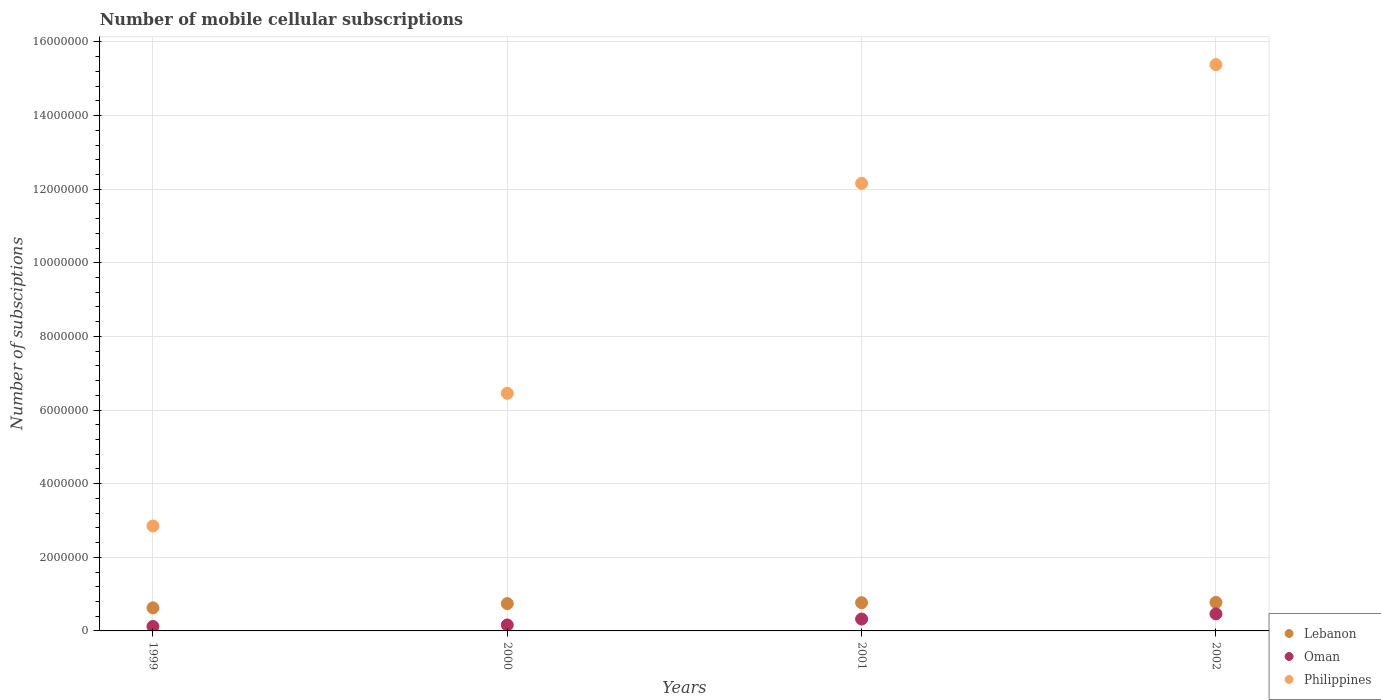How many different coloured dotlines are there?
Provide a short and direct response. 3. Is the number of dotlines equal to the number of legend labels?
Keep it short and to the point. Yes. What is the number of mobile cellular subscriptions in Philippines in 1999?
Ensure brevity in your answer.  2.85e+06. Across all years, what is the maximum number of mobile cellular subscriptions in Philippines?
Your answer should be compact. 1.54e+07. Across all years, what is the minimum number of mobile cellular subscriptions in Oman?
Provide a short and direct response. 1.21e+05. In which year was the number of mobile cellular subscriptions in Oman minimum?
Give a very brief answer. 1999. What is the total number of mobile cellular subscriptions in Lebanon in the graph?
Ensure brevity in your answer.  2.91e+06. What is the difference between the number of mobile cellular subscriptions in Philippines in 2001 and that in 2002?
Your response must be concise. -3.22e+06. What is the difference between the number of mobile cellular subscriptions in Oman in 2000 and the number of mobile cellular subscriptions in Philippines in 2001?
Ensure brevity in your answer.  -1.20e+07. What is the average number of mobile cellular subscriptions in Lebanon per year?
Provide a succinct answer. 7.28e+05. In the year 2001, what is the difference between the number of mobile cellular subscriptions in Philippines and number of mobile cellular subscriptions in Lebanon?
Your response must be concise. 1.14e+07. What is the ratio of the number of mobile cellular subscriptions in Philippines in 2000 to that in 2002?
Keep it short and to the point. 0.42. What is the difference between the highest and the second highest number of mobile cellular subscriptions in Oman?
Keep it short and to the point. 1.40e+05. What is the difference between the highest and the lowest number of mobile cellular subscriptions in Oman?
Your answer should be very brief. 3.42e+05. In how many years, is the number of mobile cellular subscriptions in Philippines greater than the average number of mobile cellular subscriptions in Philippines taken over all years?
Your response must be concise. 2. Is it the case that in every year, the sum of the number of mobile cellular subscriptions in Oman and number of mobile cellular subscriptions in Philippines  is greater than the number of mobile cellular subscriptions in Lebanon?
Provide a succinct answer. Yes. Does the number of mobile cellular subscriptions in Lebanon monotonically increase over the years?
Your answer should be compact. Yes. Is the number of mobile cellular subscriptions in Lebanon strictly greater than the number of mobile cellular subscriptions in Philippines over the years?
Ensure brevity in your answer.  No. Is the number of mobile cellular subscriptions in Philippines strictly less than the number of mobile cellular subscriptions in Oman over the years?
Give a very brief answer. No. What is the difference between two consecutive major ticks on the Y-axis?
Your response must be concise. 2.00e+06. Does the graph contain any zero values?
Provide a succinct answer. No. Where does the legend appear in the graph?
Your response must be concise. Bottom right. How many legend labels are there?
Offer a terse response. 3. How are the legend labels stacked?
Your answer should be very brief. Vertical. What is the title of the graph?
Offer a terse response. Number of mobile cellular subscriptions. Does "Georgia" appear as one of the legend labels in the graph?
Your response must be concise. No. What is the label or title of the Y-axis?
Your answer should be compact. Number of subsciptions. What is the Number of subsciptions in Lebanon in 1999?
Ensure brevity in your answer.  6.27e+05. What is the Number of subsciptions of Oman in 1999?
Ensure brevity in your answer.  1.21e+05. What is the Number of subsciptions of Philippines in 1999?
Make the answer very short. 2.85e+06. What is the Number of subsciptions in Lebanon in 2000?
Make the answer very short. 7.43e+05. What is the Number of subsciptions of Oman in 2000?
Your answer should be very brief. 1.62e+05. What is the Number of subsciptions in Philippines in 2000?
Your answer should be compact. 6.45e+06. What is the Number of subsciptions in Lebanon in 2001?
Your answer should be compact. 7.67e+05. What is the Number of subsciptions of Oman in 2001?
Ensure brevity in your answer.  3.23e+05. What is the Number of subsciptions in Philippines in 2001?
Ensure brevity in your answer.  1.22e+07. What is the Number of subsciptions of Lebanon in 2002?
Ensure brevity in your answer.  7.75e+05. What is the Number of subsciptions in Oman in 2002?
Your answer should be compact. 4.63e+05. What is the Number of subsciptions in Philippines in 2002?
Make the answer very short. 1.54e+07. Across all years, what is the maximum Number of subsciptions in Lebanon?
Provide a short and direct response. 7.75e+05. Across all years, what is the maximum Number of subsciptions of Oman?
Provide a succinct answer. 4.63e+05. Across all years, what is the maximum Number of subsciptions of Philippines?
Give a very brief answer. 1.54e+07. Across all years, what is the minimum Number of subsciptions of Lebanon?
Your answer should be compact. 6.27e+05. Across all years, what is the minimum Number of subsciptions in Oman?
Your response must be concise. 1.21e+05. Across all years, what is the minimum Number of subsciptions in Philippines?
Make the answer very short. 2.85e+06. What is the total Number of subsciptions of Lebanon in the graph?
Offer a very short reply. 2.91e+06. What is the total Number of subsciptions in Oman in the graph?
Offer a very short reply. 1.07e+06. What is the total Number of subsciptions of Philippines in the graph?
Your response must be concise. 3.68e+07. What is the difference between the Number of subsciptions in Lebanon in 1999 and that in 2000?
Ensure brevity in your answer.  -1.16e+05. What is the difference between the Number of subsciptions in Oman in 1999 and that in 2000?
Your answer should be very brief. -4.10e+04. What is the difference between the Number of subsciptions of Philippines in 1999 and that in 2000?
Your answer should be very brief. -3.60e+06. What is the difference between the Number of subsciptions of Lebanon in 1999 and that in 2001?
Make the answer very short. -1.40e+05. What is the difference between the Number of subsciptions of Oman in 1999 and that in 2001?
Provide a succinct answer. -2.02e+05. What is the difference between the Number of subsciptions in Philippines in 1999 and that in 2001?
Provide a short and direct response. -9.31e+06. What is the difference between the Number of subsciptions of Lebanon in 1999 and that in 2002?
Ensure brevity in your answer.  -1.48e+05. What is the difference between the Number of subsciptions in Oman in 1999 and that in 2002?
Offer a very short reply. -3.42e+05. What is the difference between the Number of subsciptions in Philippines in 1999 and that in 2002?
Ensure brevity in your answer.  -1.25e+07. What is the difference between the Number of subsciptions of Lebanon in 2000 and that in 2001?
Provide a succinct answer. -2.38e+04. What is the difference between the Number of subsciptions of Oman in 2000 and that in 2001?
Make the answer very short. -1.61e+05. What is the difference between the Number of subsciptions in Philippines in 2000 and that in 2001?
Provide a short and direct response. -5.70e+06. What is the difference between the Number of subsciptions of Lebanon in 2000 and that in 2002?
Provide a succinct answer. -3.21e+04. What is the difference between the Number of subsciptions of Oman in 2000 and that in 2002?
Your answer should be compact. -3.01e+05. What is the difference between the Number of subsciptions in Philippines in 2000 and that in 2002?
Keep it short and to the point. -8.93e+06. What is the difference between the Number of subsciptions of Lebanon in 2001 and that in 2002?
Ensure brevity in your answer.  -8350. What is the difference between the Number of subsciptions of Philippines in 2001 and that in 2002?
Your answer should be compact. -3.22e+06. What is the difference between the Number of subsciptions in Lebanon in 1999 and the Number of subsciptions in Oman in 2000?
Your answer should be compact. 4.65e+05. What is the difference between the Number of subsciptions in Lebanon in 1999 and the Number of subsciptions in Philippines in 2000?
Provide a short and direct response. -5.83e+06. What is the difference between the Number of subsciptions of Oman in 1999 and the Number of subsciptions of Philippines in 2000?
Offer a very short reply. -6.33e+06. What is the difference between the Number of subsciptions of Lebanon in 1999 and the Number of subsciptions of Oman in 2001?
Make the answer very short. 3.04e+05. What is the difference between the Number of subsciptions of Lebanon in 1999 and the Number of subsciptions of Philippines in 2001?
Give a very brief answer. -1.15e+07. What is the difference between the Number of subsciptions of Oman in 1999 and the Number of subsciptions of Philippines in 2001?
Provide a succinct answer. -1.20e+07. What is the difference between the Number of subsciptions of Lebanon in 1999 and the Number of subsciptions of Oman in 2002?
Your answer should be very brief. 1.64e+05. What is the difference between the Number of subsciptions in Lebanon in 1999 and the Number of subsciptions in Philippines in 2002?
Provide a short and direct response. -1.48e+07. What is the difference between the Number of subsciptions in Oman in 1999 and the Number of subsciptions in Philippines in 2002?
Ensure brevity in your answer.  -1.53e+07. What is the difference between the Number of subsciptions of Lebanon in 2000 and the Number of subsciptions of Oman in 2001?
Offer a terse response. 4.20e+05. What is the difference between the Number of subsciptions of Lebanon in 2000 and the Number of subsciptions of Philippines in 2001?
Provide a short and direct response. -1.14e+07. What is the difference between the Number of subsciptions in Oman in 2000 and the Number of subsciptions in Philippines in 2001?
Your response must be concise. -1.20e+07. What is the difference between the Number of subsciptions in Lebanon in 2000 and the Number of subsciptions in Oman in 2002?
Your answer should be compact. 2.80e+05. What is the difference between the Number of subsciptions of Lebanon in 2000 and the Number of subsciptions of Philippines in 2002?
Offer a very short reply. -1.46e+07. What is the difference between the Number of subsciptions in Oman in 2000 and the Number of subsciptions in Philippines in 2002?
Make the answer very short. -1.52e+07. What is the difference between the Number of subsciptions of Lebanon in 2001 and the Number of subsciptions of Oman in 2002?
Your response must be concise. 3.04e+05. What is the difference between the Number of subsciptions of Lebanon in 2001 and the Number of subsciptions of Philippines in 2002?
Provide a short and direct response. -1.46e+07. What is the difference between the Number of subsciptions in Oman in 2001 and the Number of subsciptions in Philippines in 2002?
Your answer should be compact. -1.51e+07. What is the average Number of subsciptions in Lebanon per year?
Your answer should be very brief. 7.28e+05. What is the average Number of subsciptions in Oman per year?
Keep it short and to the point. 2.67e+05. What is the average Number of subsciptions in Philippines per year?
Make the answer very short. 9.21e+06. In the year 1999, what is the difference between the Number of subsciptions in Lebanon and Number of subsciptions in Oman?
Provide a short and direct response. 5.06e+05. In the year 1999, what is the difference between the Number of subsciptions of Lebanon and Number of subsciptions of Philippines?
Ensure brevity in your answer.  -2.22e+06. In the year 1999, what is the difference between the Number of subsciptions of Oman and Number of subsciptions of Philippines?
Your response must be concise. -2.73e+06. In the year 2000, what is the difference between the Number of subsciptions in Lebanon and Number of subsciptions in Oman?
Ensure brevity in your answer.  5.81e+05. In the year 2000, what is the difference between the Number of subsciptions in Lebanon and Number of subsciptions in Philippines?
Your answer should be very brief. -5.71e+06. In the year 2000, what is the difference between the Number of subsciptions of Oman and Number of subsciptions of Philippines?
Ensure brevity in your answer.  -6.29e+06. In the year 2001, what is the difference between the Number of subsciptions in Lebanon and Number of subsciptions in Oman?
Give a very brief answer. 4.44e+05. In the year 2001, what is the difference between the Number of subsciptions in Lebanon and Number of subsciptions in Philippines?
Your answer should be very brief. -1.14e+07. In the year 2001, what is the difference between the Number of subsciptions of Oman and Number of subsciptions of Philippines?
Provide a short and direct response. -1.18e+07. In the year 2002, what is the difference between the Number of subsciptions in Lebanon and Number of subsciptions in Oman?
Your answer should be very brief. 3.12e+05. In the year 2002, what is the difference between the Number of subsciptions of Lebanon and Number of subsciptions of Philippines?
Your response must be concise. -1.46e+07. In the year 2002, what is the difference between the Number of subsciptions in Oman and Number of subsciptions in Philippines?
Make the answer very short. -1.49e+07. What is the ratio of the Number of subsciptions in Lebanon in 1999 to that in 2000?
Give a very brief answer. 0.84. What is the ratio of the Number of subsciptions in Oman in 1999 to that in 2000?
Keep it short and to the point. 0.75. What is the ratio of the Number of subsciptions in Philippines in 1999 to that in 2000?
Provide a short and direct response. 0.44. What is the ratio of the Number of subsciptions of Lebanon in 1999 to that in 2001?
Provide a succinct answer. 0.82. What is the ratio of the Number of subsciptions in Oman in 1999 to that in 2001?
Ensure brevity in your answer.  0.37. What is the ratio of the Number of subsciptions of Philippines in 1999 to that in 2001?
Your answer should be very brief. 0.23. What is the ratio of the Number of subsciptions of Lebanon in 1999 to that in 2002?
Give a very brief answer. 0.81. What is the ratio of the Number of subsciptions in Oman in 1999 to that in 2002?
Your response must be concise. 0.26. What is the ratio of the Number of subsciptions of Philippines in 1999 to that in 2002?
Provide a succinct answer. 0.19. What is the ratio of the Number of subsciptions of Lebanon in 2000 to that in 2001?
Your answer should be very brief. 0.97. What is the ratio of the Number of subsciptions in Oman in 2000 to that in 2001?
Offer a very short reply. 0.5. What is the ratio of the Number of subsciptions of Philippines in 2000 to that in 2001?
Your answer should be very brief. 0.53. What is the ratio of the Number of subsciptions of Lebanon in 2000 to that in 2002?
Ensure brevity in your answer.  0.96. What is the ratio of the Number of subsciptions in Oman in 2000 to that in 2002?
Your answer should be compact. 0.35. What is the ratio of the Number of subsciptions of Philippines in 2000 to that in 2002?
Ensure brevity in your answer.  0.42. What is the ratio of the Number of subsciptions in Lebanon in 2001 to that in 2002?
Provide a succinct answer. 0.99. What is the ratio of the Number of subsciptions in Oman in 2001 to that in 2002?
Your answer should be compact. 0.7. What is the ratio of the Number of subsciptions in Philippines in 2001 to that in 2002?
Your response must be concise. 0.79. What is the difference between the highest and the second highest Number of subsciptions of Lebanon?
Your response must be concise. 8350. What is the difference between the highest and the second highest Number of subsciptions in Oman?
Keep it short and to the point. 1.40e+05. What is the difference between the highest and the second highest Number of subsciptions in Philippines?
Your answer should be compact. 3.22e+06. What is the difference between the highest and the lowest Number of subsciptions in Lebanon?
Give a very brief answer. 1.48e+05. What is the difference between the highest and the lowest Number of subsciptions of Oman?
Keep it short and to the point. 3.42e+05. What is the difference between the highest and the lowest Number of subsciptions of Philippines?
Provide a short and direct response. 1.25e+07. 